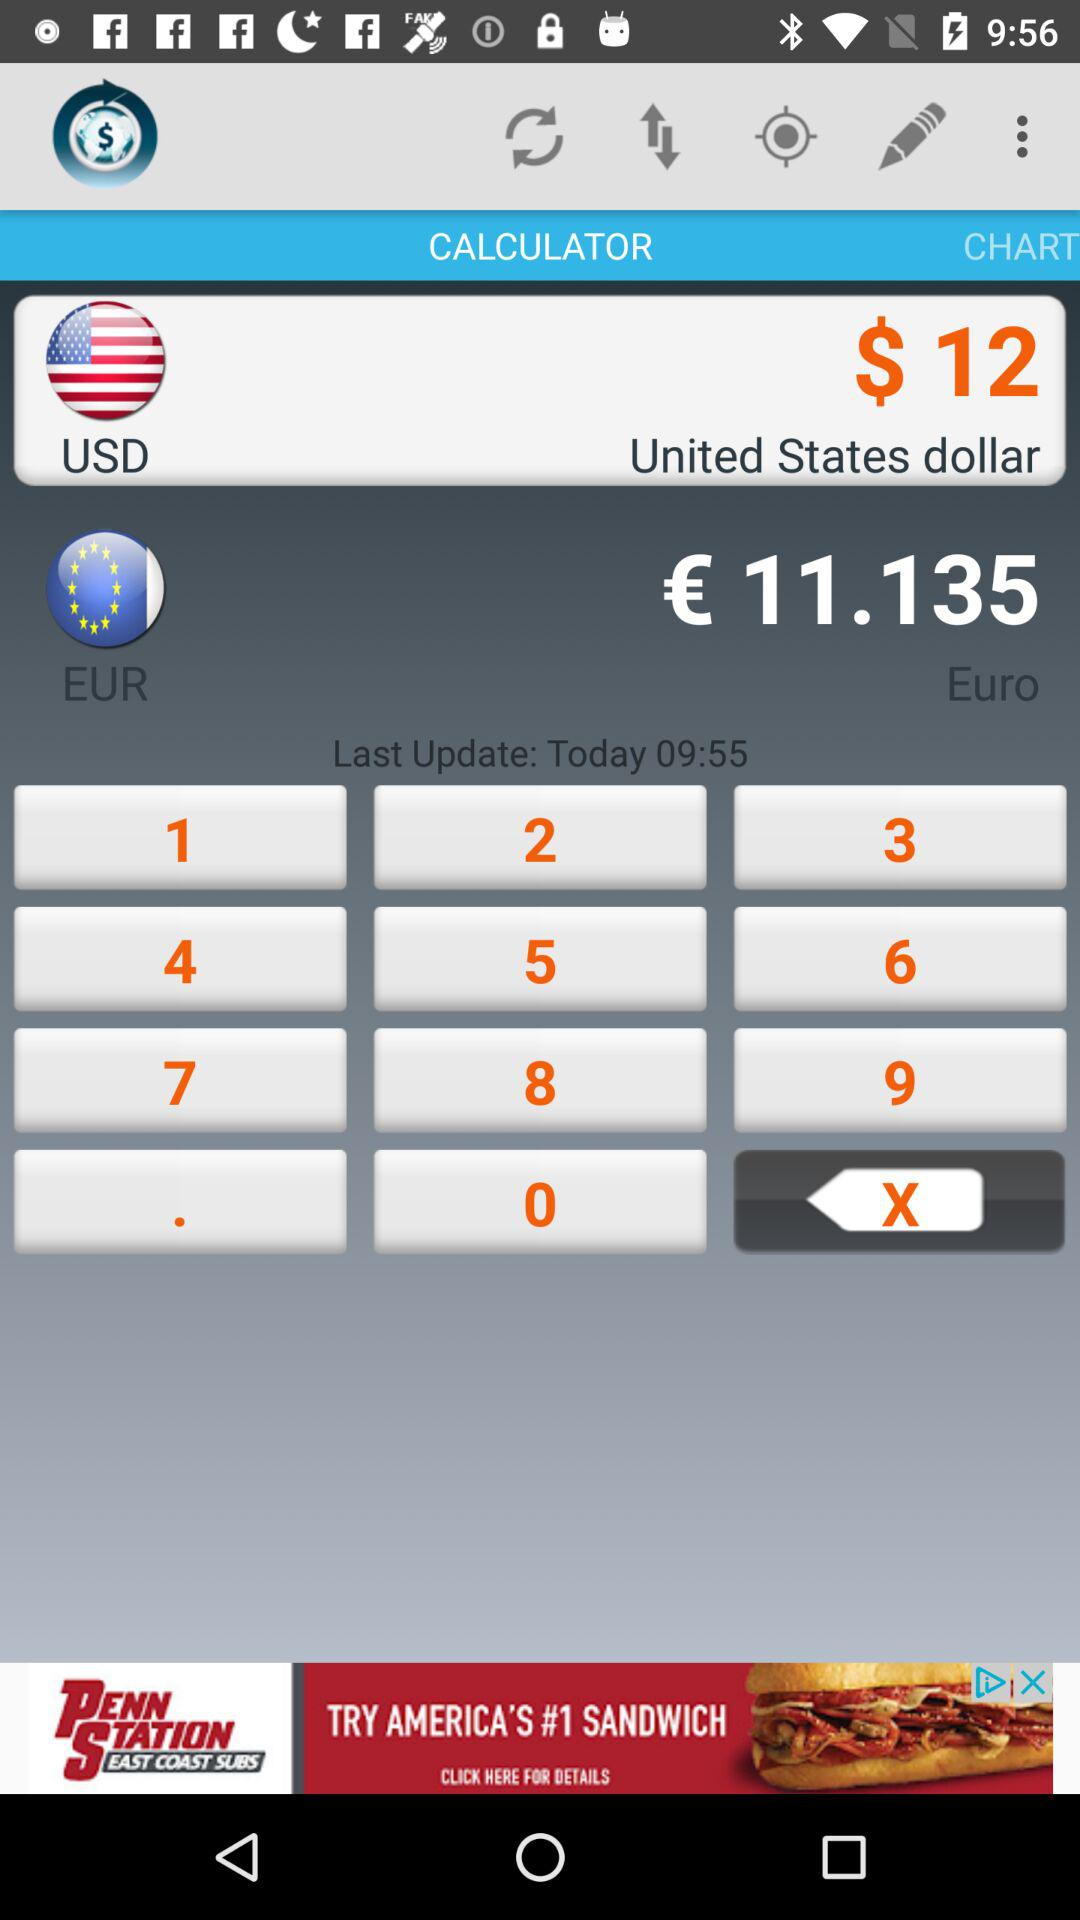How many items are in "CHART"?
When the provided information is insufficient, respond with <no answer>. <no answer> 